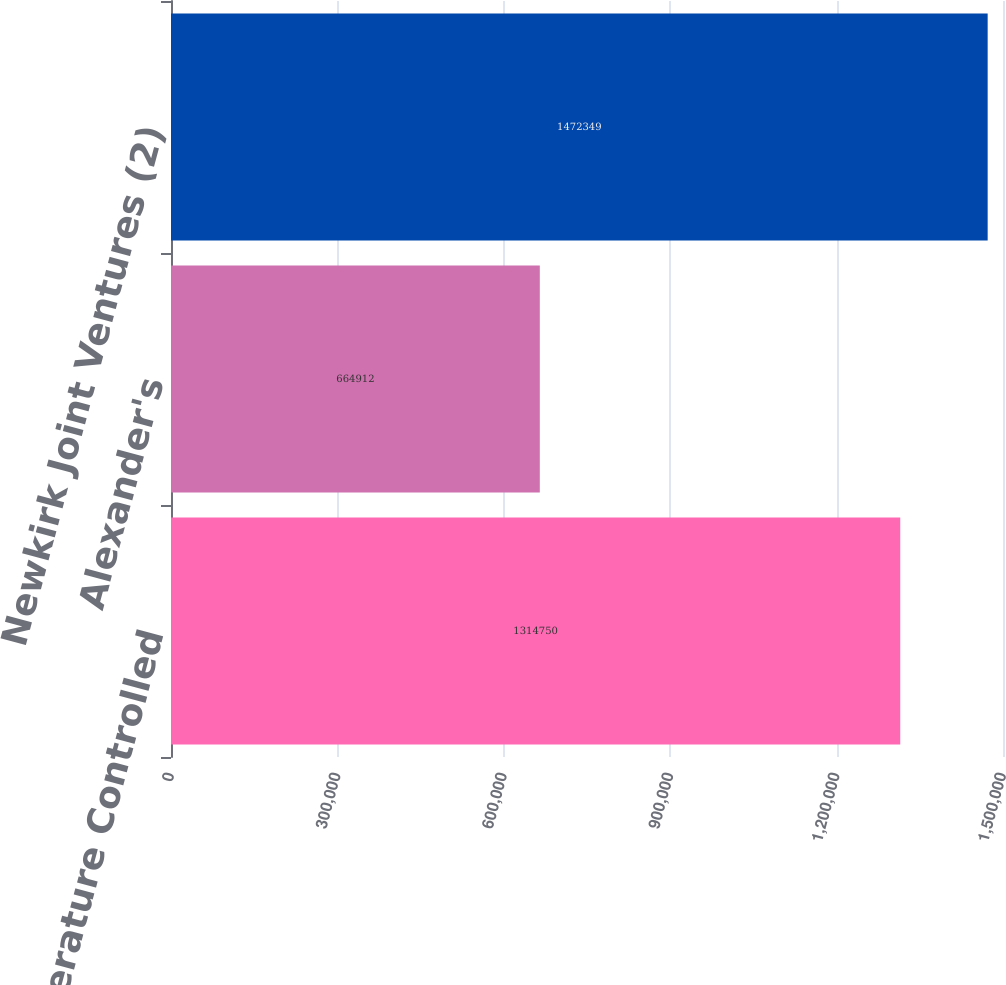<chart> <loc_0><loc_0><loc_500><loc_500><bar_chart><fcel>Temperature Controlled<fcel>Alexander's<fcel>Newkirk Joint Ventures (2)<nl><fcel>1.31475e+06<fcel>664912<fcel>1.47235e+06<nl></chart> 